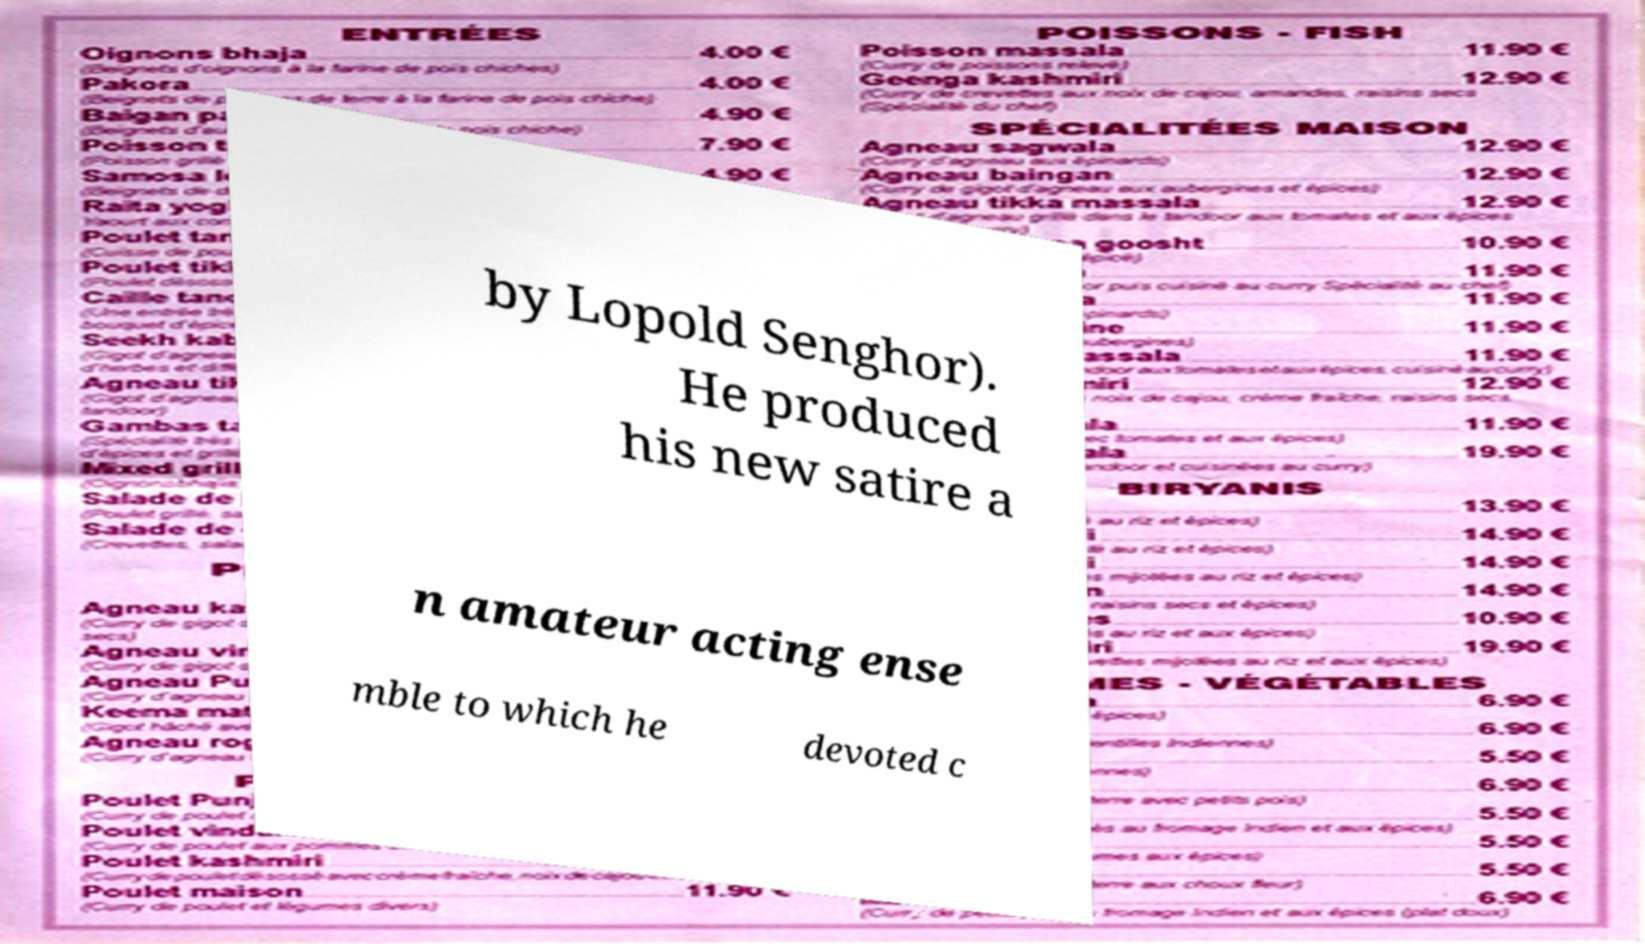Can you read and provide the text displayed in the image?This photo seems to have some interesting text. Can you extract and type it out for me? by Lopold Senghor). He produced his new satire a n amateur acting ense mble to which he devoted c 